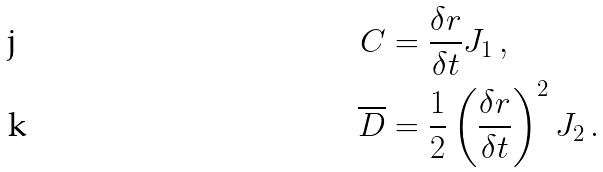Convert formula to latex. <formula><loc_0><loc_0><loc_500><loc_500>C & = \frac { \delta r } { \delta t } J _ { 1 } \, , \\ \overline { D } & = \frac { 1 } { 2 } \left ( \frac { \delta r } { \delta t } \right ) ^ { 2 } J _ { 2 } \, .</formula> 